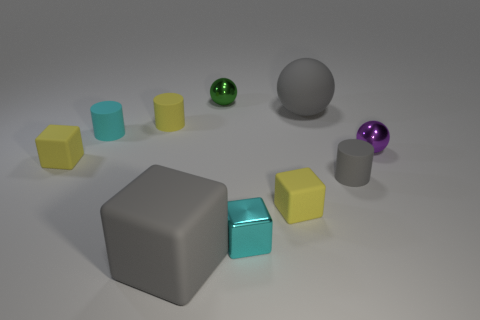Subtract all metal cubes. How many cubes are left? 3 Subtract 1 cylinders. How many cylinders are left? 2 Subtract all gray balls. How many balls are left? 2 Subtract 1 gray balls. How many objects are left? 9 Subtract all cubes. How many objects are left? 6 Subtract all green cylinders. Subtract all red blocks. How many cylinders are left? 3 Subtract all brown blocks. How many yellow spheres are left? 0 Subtract all small gray cylinders. Subtract all big gray matte cubes. How many objects are left? 8 Add 8 gray rubber cylinders. How many gray rubber cylinders are left? 9 Add 1 big purple matte spheres. How many big purple matte spheres exist? 1 